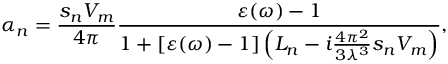Convert formula to latex. <formula><loc_0><loc_0><loc_500><loc_500>\alpha _ { n } = \frac { s _ { n } V _ { m } } { 4 \pi } \frac { \varepsilon ( \omega ) - 1 } { 1 + [ \varepsilon ( \omega ) - 1 ] \left ( L _ { n } - i \frac { 4 \pi ^ { 2 } } { 3 \lambda ^ { 3 } } s _ { n } V _ { m } \right ) } ,</formula> 